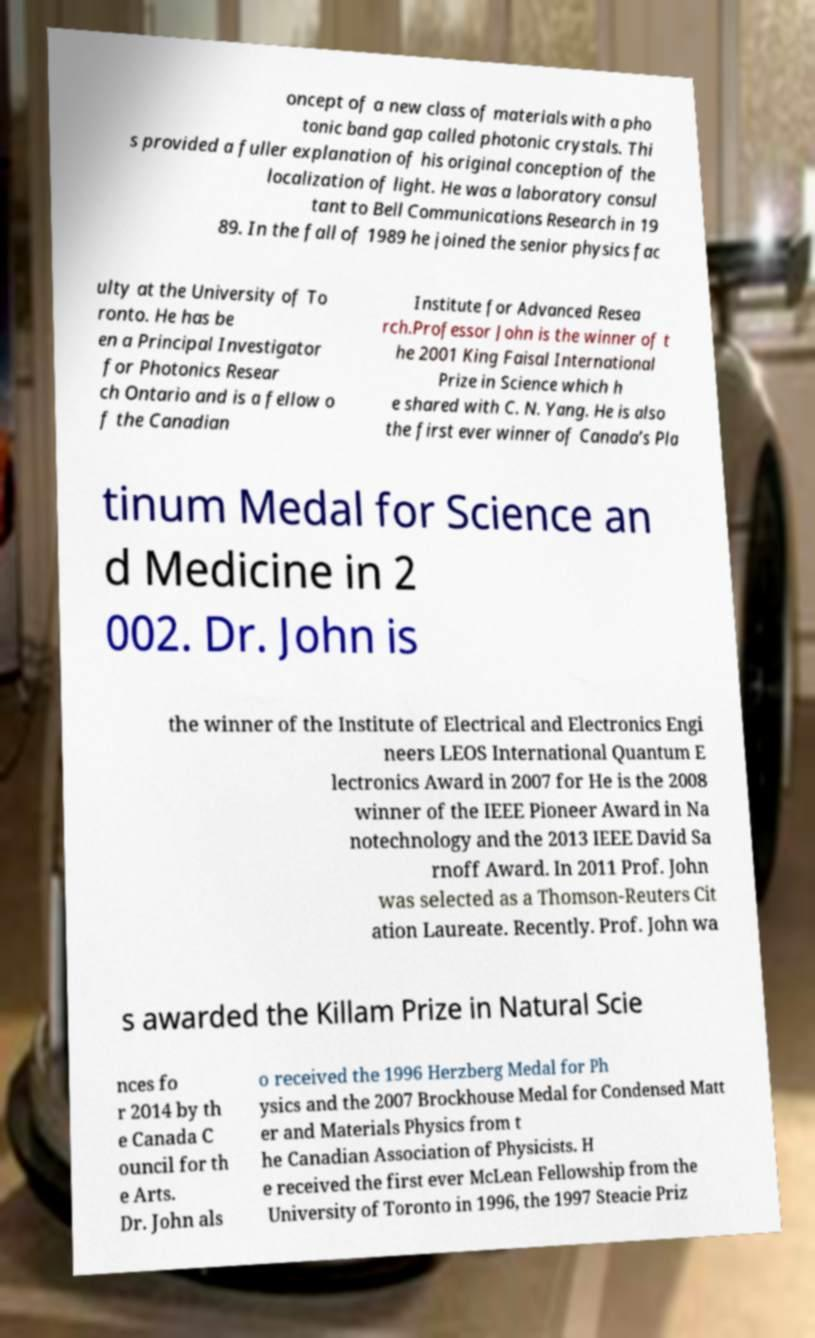I need the written content from this picture converted into text. Can you do that? oncept of a new class of materials with a pho tonic band gap called photonic crystals. Thi s provided a fuller explanation of his original conception of the localization of light. He was a laboratory consul tant to Bell Communications Research in 19 89. In the fall of 1989 he joined the senior physics fac ulty at the University of To ronto. He has be en a Principal Investigator for Photonics Resear ch Ontario and is a fellow o f the Canadian Institute for Advanced Resea rch.Professor John is the winner of t he 2001 King Faisal International Prize in Science which h e shared with C. N. Yang. He is also the first ever winner of Canada’s Pla tinum Medal for Science an d Medicine in 2 002. Dr. John is the winner of the Institute of Electrical and Electronics Engi neers LEOS International Quantum E lectronics Award in 2007 for He is the 2008 winner of the IEEE Pioneer Award in Na notechnology and the 2013 IEEE David Sa rnoff Award. In 2011 Prof. John was selected as a Thomson-Reuters Cit ation Laureate. Recently. Prof. John wa s awarded the Killam Prize in Natural Scie nces fo r 2014 by th e Canada C ouncil for th e Arts. Dr. John als o received the 1996 Herzberg Medal for Ph ysics and the 2007 Brockhouse Medal for Condensed Matt er and Materials Physics from t he Canadian Association of Physicists. H e received the first ever McLean Fellowship from the University of Toronto in 1996, the 1997 Steacie Priz 